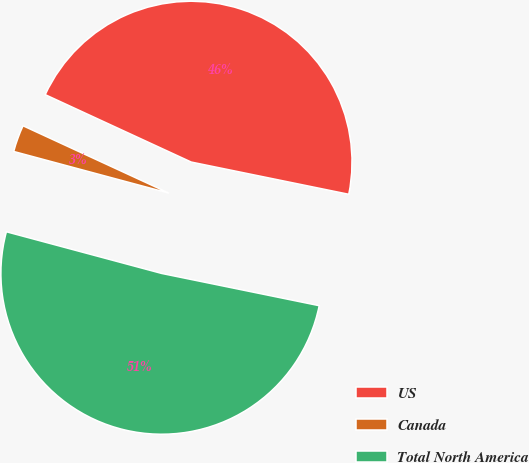<chart> <loc_0><loc_0><loc_500><loc_500><pie_chart><fcel>US<fcel>Canada<fcel>Total North America<nl><fcel>46.33%<fcel>2.71%<fcel>50.96%<nl></chart> 